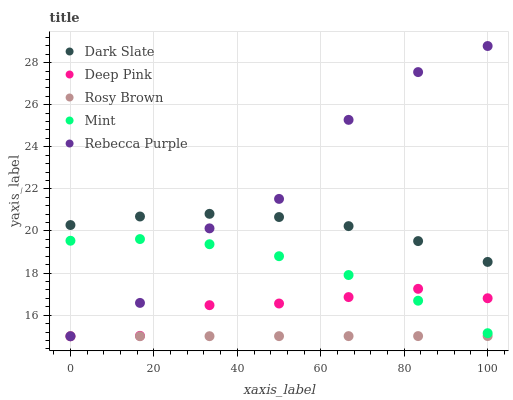Does Rosy Brown have the minimum area under the curve?
Answer yes or no. Yes. Does Rebecca Purple have the maximum area under the curve?
Answer yes or no. Yes. Does Deep Pink have the minimum area under the curve?
Answer yes or no. No. Does Deep Pink have the maximum area under the curve?
Answer yes or no. No. Is Rosy Brown the smoothest?
Answer yes or no. Yes. Is Rebecca Purple the roughest?
Answer yes or no. Yes. Is Deep Pink the smoothest?
Answer yes or no. No. Is Deep Pink the roughest?
Answer yes or no. No. Does Rosy Brown have the lowest value?
Answer yes or no. Yes. Does Mint have the lowest value?
Answer yes or no. No. Does Rebecca Purple have the highest value?
Answer yes or no. Yes. Does Deep Pink have the highest value?
Answer yes or no. No. Is Rosy Brown less than Dark Slate?
Answer yes or no. Yes. Is Dark Slate greater than Deep Pink?
Answer yes or no. Yes. Does Rebecca Purple intersect Rosy Brown?
Answer yes or no. Yes. Is Rebecca Purple less than Rosy Brown?
Answer yes or no. No. Is Rebecca Purple greater than Rosy Brown?
Answer yes or no. No. Does Rosy Brown intersect Dark Slate?
Answer yes or no. No. 